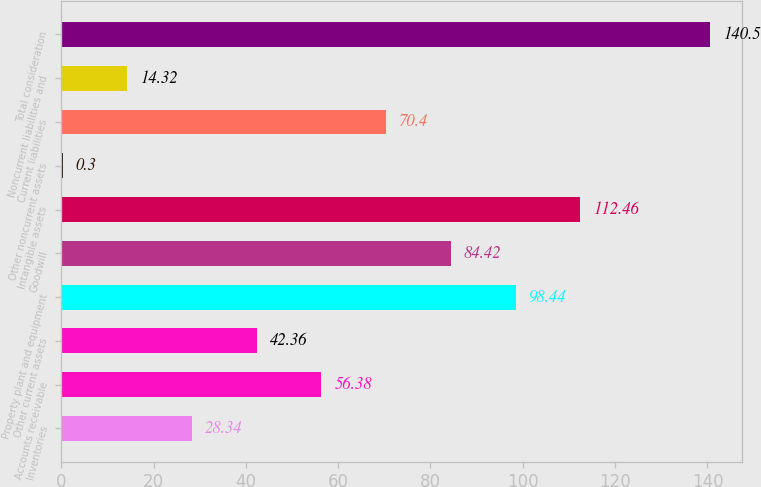<chart> <loc_0><loc_0><loc_500><loc_500><bar_chart><fcel>Inventories<fcel>Accounts receivable<fcel>Other current assets<fcel>Property plant and equipment<fcel>Goodwill<fcel>Intangible assets<fcel>Other noncurrent assets<fcel>Current liabilities<fcel>Noncurrent liabilities and<fcel>Total consideration<nl><fcel>28.34<fcel>56.38<fcel>42.36<fcel>98.44<fcel>84.42<fcel>112.46<fcel>0.3<fcel>70.4<fcel>14.32<fcel>140.5<nl></chart> 